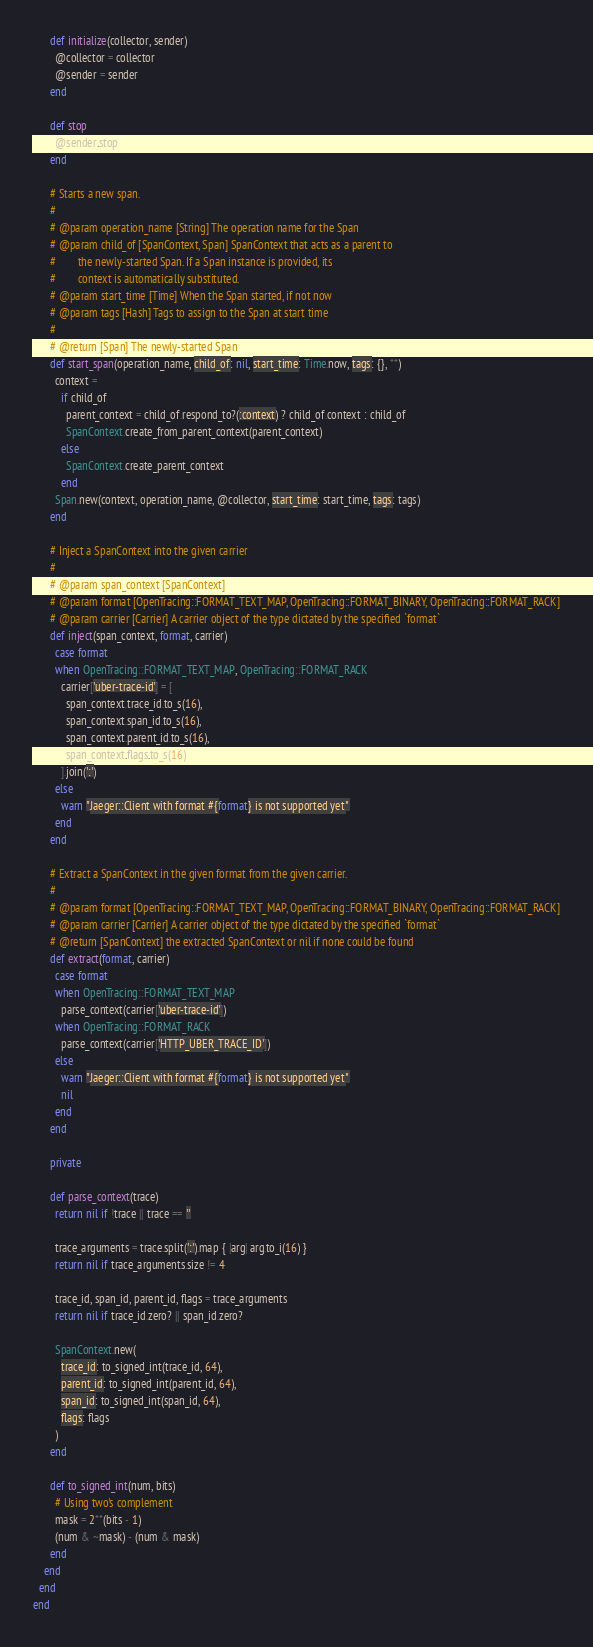Convert code to text. <code><loc_0><loc_0><loc_500><loc_500><_Ruby_>      def initialize(collector, sender)
        @collector = collector
        @sender = sender
      end

      def stop
        @sender.stop
      end

      # Starts a new span.
      #
      # @param operation_name [String] The operation name for the Span
      # @param child_of [SpanContext, Span] SpanContext that acts as a parent to
      #        the newly-started Span. If a Span instance is provided, its
      #        context is automatically substituted.
      # @param start_time [Time] When the Span started, if not now
      # @param tags [Hash] Tags to assign to the Span at start time
      #
      # @return [Span] The newly-started Span
      def start_span(operation_name, child_of: nil, start_time: Time.now, tags: {}, **)
        context =
          if child_of
            parent_context = child_of.respond_to?(:context) ? child_of.context : child_of
            SpanContext.create_from_parent_context(parent_context)
          else
            SpanContext.create_parent_context
          end
        Span.new(context, operation_name, @collector, start_time: start_time, tags: tags)
      end

      # Inject a SpanContext into the given carrier
      #
      # @param span_context [SpanContext]
      # @param format [OpenTracing::FORMAT_TEXT_MAP, OpenTracing::FORMAT_BINARY, OpenTracing::FORMAT_RACK]
      # @param carrier [Carrier] A carrier object of the type dictated by the specified `format`
      def inject(span_context, format, carrier)
        case format
        when OpenTracing::FORMAT_TEXT_MAP, OpenTracing::FORMAT_RACK
          carrier['uber-trace-id'] = [
            span_context.trace_id.to_s(16),
            span_context.span_id.to_s(16),
            span_context.parent_id.to_s(16),
            span_context.flags.to_s(16)
          ].join(':')
        else
          warn "Jaeger::Client with format #{format} is not supported yet"
        end
      end

      # Extract a SpanContext in the given format from the given carrier.
      #
      # @param format [OpenTracing::FORMAT_TEXT_MAP, OpenTracing::FORMAT_BINARY, OpenTracing::FORMAT_RACK]
      # @param carrier [Carrier] A carrier object of the type dictated by the specified `format`
      # @return [SpanContext] the extracted SpanContext or nil if none could be found
      def extract(format, carrier)
        case format
        when OpenTracing::FORMAT_TEXT_MAP
          parse_context(carrier['uber-trace-id'])
        when OpenTracing::FORMAT_RACK
          parse_context(carrier['HTTP_UBER_TRACE_ID'])
        else
          warn "Jaeger::Client with format #{format} is not supported yet"
          nil
        end
      end

      private

      def parse_context(trace)
        return nil if !trace || trace == ''

        trace_arguments = trace.split(':').map { |arg| arg.to_i(16) }
        return nil if trace_arguments.size != 4

        trace_id, span_id, parent_id, flags = trace_arguments
        return nil if trace_id.zero? || span_id.zero?

        SpanContext.new(
          trace_id: to_signed_int(trace_id, 64),
          parent_id: to_signed_int(parent_id, 64),
          span_id: to_signed_int(span_id, 64),
          flags: flags
        )
      end

      def to_signed_int(num, bits)
        # Using two's complement
        mask = 2**(bits - 1)
        (num & ~mask) - (num & mask)
      end
    end
  end
end
</code> 